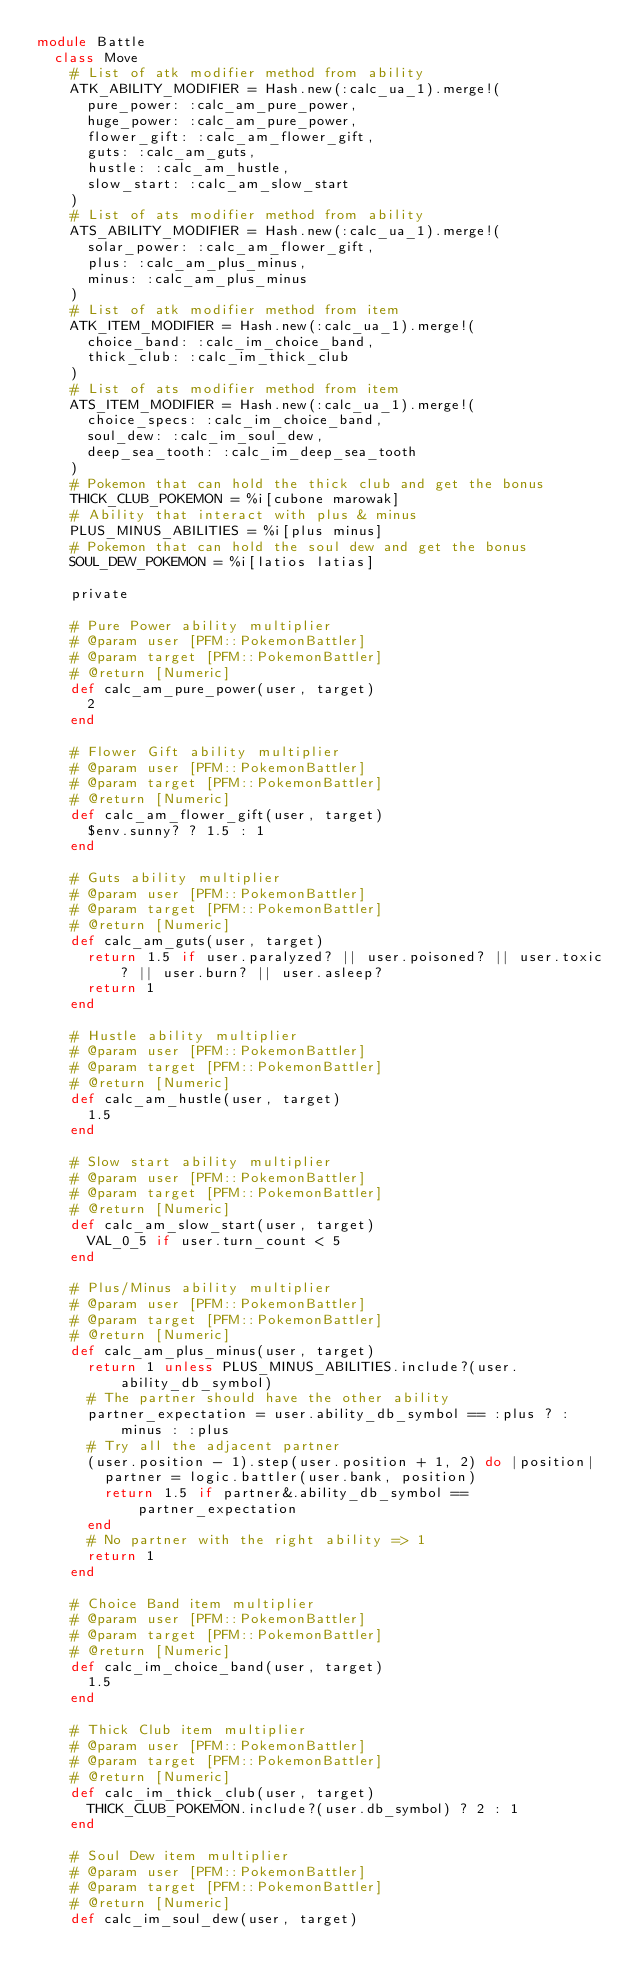Convert code to text. <code><loc_0><loc_0><loc_500><loc_500><_Ruby_>module Battle
  class Move
    # List of atk modifier method from ability
    ATK_ABILITY_MODIFIER = Hash.new(:calc_ua_1).merge!(
      pure_power: :calc_am_pure_power,
      huge_power: :calc_am_pure_power,
      flower_gift: :calc_am_flower_gift,
      guts: :calc_am_guts,
      hustle: :calc_am_hustle,
      slow_start: :calc_am_slow_start
    )
    # List of ats modifier method from ability
    ATS_ABILITY_MODIFIER = Hash.new(:calc_ua_1).merge!(
      solar_power: :calc_am_flower_gift,
      plus: :calc_am_plus_minus,
      minus: :calc_am_plus_minus
    )
    # List of atk modifier method from item
    ATK_ITEM_MODIFIER = Hash.new(:calc_ua_1).merge!(
      choice_band: :calc_im_choice_band,
      thick_club: :calc_im_thick_club
    )
    # List of ats modifier method from item
    ATS_ITEM_MODIFIER = Hash.new(:calc_ua_1).merge!(
      choice_specs: :calc_im_choice_band,
      soul_dew: :calc_im_soul_dew,
      deep_sea_tooth: :calc_im_deep_sea_tooth
    )
    # Pokemon that can hold the thick club and get the bonus
    THICK_CLUB_POKEMON = %i[cubone marowak]
    # Ability that interact with plus & minus
    PLUS_MINUS_ABILITIES = %i[plus minus]
    # Pokemon that can hold the soul dew and get the bonus
    SOUL_DEW_POKEMON = %i[latios latias]

    private

    # Pure Power ability multiplier
    # @param user [PFM::PokemonBattler]
    # @param target [PFM::PokemonBattler]
    # @return [Numeric]
    def calc_am_pure_power(user, target)
      2
    end

    # Flower Gift ability multiplier
    # @param user [PFM::PokemonBattler]
    # @param target [PFM::PokemonBattler]
    # @return [Numeric]
    def calc_am_flower_gift(user, target)
      $env.sunny? ? 1.5 : 1
    end

    # Guts ability multiplier
    # @param user [PFM::PokemonBattler]
    # @param target [PFM::PokemonBattler]
    # @return [Numeric]
    def calc_am_guts(user, target)
      return 1.5 if user.paralyzed? || user.poisoned? || user.toxic? || user.burn? || user.asleep?
      return 1
    end

    # Hustle ability multiplier
    # @param user [PFM::PokemonBattler]
    # @param target [PFM::PokemonBattler]
    # @return [Numeric]
    def calc_am_hustle(user, target)
      1.5
    end

    # Slow start ability multiplier
    # @param user [PFM::PokemonBattler]
    # @param target [PFM::PokemonBattler]
    # @return [Numeric]
    def calc_am_slow_start(user, target)
      VAL_0_5 if user.turn_count < 5
    end

    # Plus/Minus ability multiplier
    # @param user [PFM::PokemonBattler]
    # @param target [PFM::PokemonBattler]
    # @return [Numeric]
    def calc_am_plus_minus(user, target)
      return 1 unless PLUS_MINUS_ABILITIES.include?(user.ability_db_symbol)
      # The partner should have the other ability
      partner_expectation = user.ability_db_symbol == :plus ? :minus : :plus
      # Try all the adjacent partner
      (user.position - 1).step(user.position + 1, 2) do |position|
        partner = logic.battler(user.bank, position)
        return 1.5 if partner&.ability_db_symbol == partner_expectation
      end
      # No partner with the right ability => 1
      return 1
    end

    # Choice Band item multiplier
    # @param user [PFM::PokemonBattler]
    # @param target [PFM::PokemonBattler]
    # @return [Numeric]
    def calc_im_choice_band(user, target)
      1.5
    end

    # Thick Club item multiplier
    # @param user [PFM::PokemonBattler]
    # @param target [PFM::PokemonBattler]
    # @return [Numeric]
    def calc_im_thick_club(user, target)
      THICK_CLUB_POKEMON.include?(user.db_symbol) ? 2 : 1
    end

    # Soul Dew item multiplier
    # @param user [PFM::PokemonBattler]
    # @param target [PFM::PokemonBattler]
    # @return [Numeric]
    def calc_im_soul_dew(user, target)</code> 